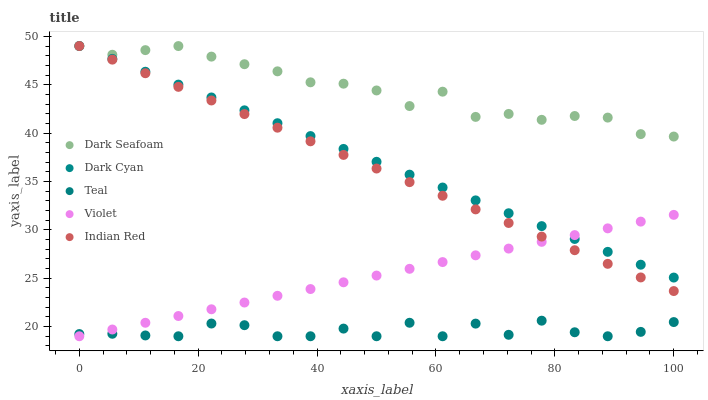Does Teal have the minimum area under the curve?
Answer yes or no. Yes. Does Dark Seafoam have the maximum area under the curve?
Answer yes or no. Yes. Does Indian Red have the minimum area under the curve?
Answer yes or no. No. Does Indian Red have the maximum area under the curve?
Answer yes or no. No. Is Indian Red the smoothest?
Answer yes or no. Yes. Is Teal the roughest?
Answer yes or no. Yes. Is Dark Seafoam the smoothest?
Answer yes or no. No. Is Dark Seafoam the roughest?
Answer yes or no. No. Does Teal have the lowest value?
Answer yes or no. Yes. Does Indian Red have the lowest value?
Answer yes or no. No. Does Indian Red have the highest value?
Answer yes or no. Yes. Does Teal have the highest value?
Answer yes or no. No. Is Violet less than Dark Seafoam?
Answer yes or no. Yes. Is Dark Seafoam greater than Violet?
Answer yes or no. Yes. Does Dark Cyan intersect Dark Seafoam?
Answer yes or no. Yes. Is Dark Cyan less than Dark Seafoam?
Answer yes or no. No. Is Dark Cyan greater than Dark Seafoam?
Answer yes or no. No. Does Violet intersect Dark Seafoam?
Answer yes or no. No. 